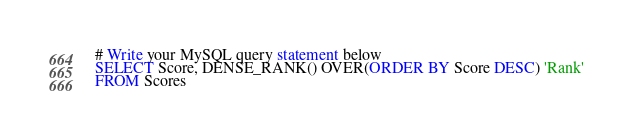Convert code to text. <code><loc_0><loc_0><loc_500><loc_500><_SQL_># Write your MySQL query statement below
SELECT Score, DENSE_RANK() OVER(ORDER BY Score DESC) 'Rank'
FROM Scores</code> 